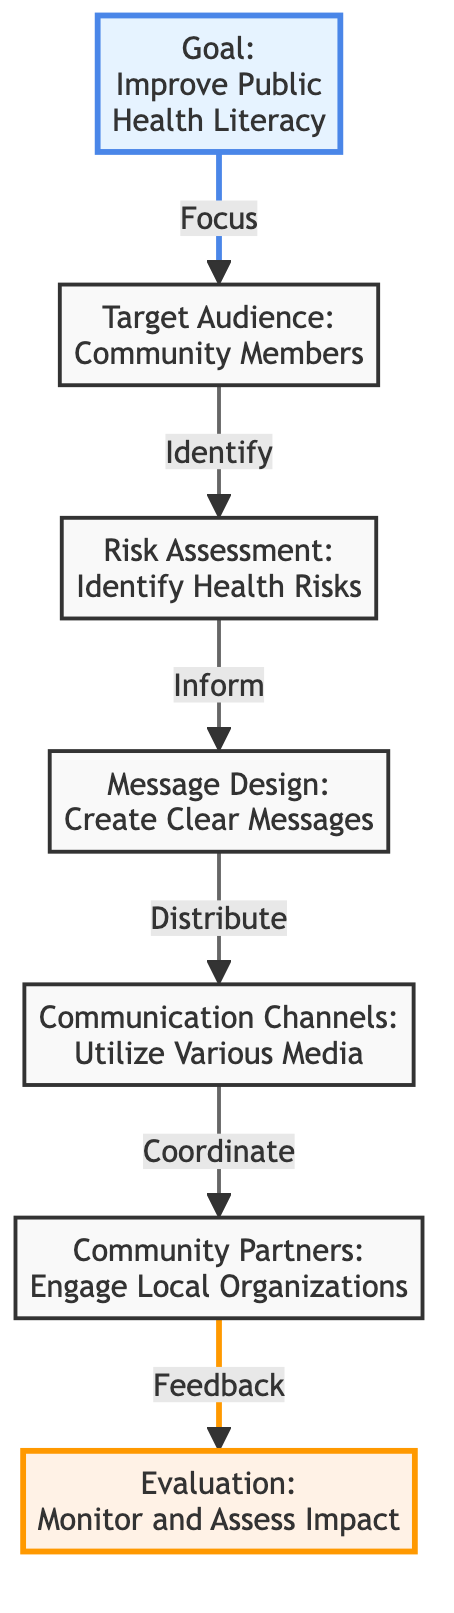What is the main goal of the diagram? The main goal is explicitly stated in the first node of the diagram, which reads "Improve Public Health Literacy." This is a clear and direct statement that defines the primary objective.
Answer: Improve Public Health Literacy How many steps are in the flow of the diagram? Counting each directed arrow that represents the transition from one node to another provides the number of steps. There are six directed transitions in total, indicating six steps to achieve the goal.
Answer: 6 What is the first step after identifying the target audience? The first step after identifying the target audience is "Risk Assessment: Identify Health Risks," which follows the arrow leading out from the target audience node.
Answer: Risk Assessment: Identify Health Risks Which node leads to the message design? The "Risk Assessment: Identify Health Risks" node leads directly to the "Message Design: Create Clear Messages" node, which follows the directed flow. This indicates that message design is informed by the preceding risk assessment.
Answer: Risk Assessment: Identify Health Risks What is the final evaluation step in the process? The last step listed in the diagram, which evaluates the overall effectiveness of the preceding steps, is "Evaluation: Monitor and Assess Impact." This is the concluding component of the process outlined in the flowchart.
Answer: Evaluation: Monitor and Assess Impact Which node is associated with community organizations? The node that relates to community organizations is "Community Partners: Engage Local Organizations." It is connected to a step focusing on coordination with community partners.
Answer: Community Partners: Engage Local Organizations What triggers the evaluation phase? The evaluation phase is triggered by feedback from the "Community Partners: Engage Local Organizations," as indicated by the directed arrow leading to the evaluation node. This highlights the importance of community input in assessing impact.
Answer: Feedback What type of channels are utilized in the communication strategy? The diagram specifies "Communication Channels: Utilize Various Media" to depict the type of channels that should be employed in the communication strategy. This implies a diversity of media usage.
Answer: Various Media 